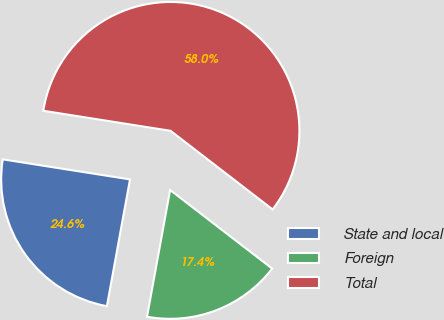Convert chart to OTSL. <chart><loc_0><loc_0><loc_500><loc_500><pie_chart><fcel>State and local<fcel>Foreign<fcel>Total<nl><fcel>24.62%<fcel>17.42%<fcel>57.96%<nl></chart> 